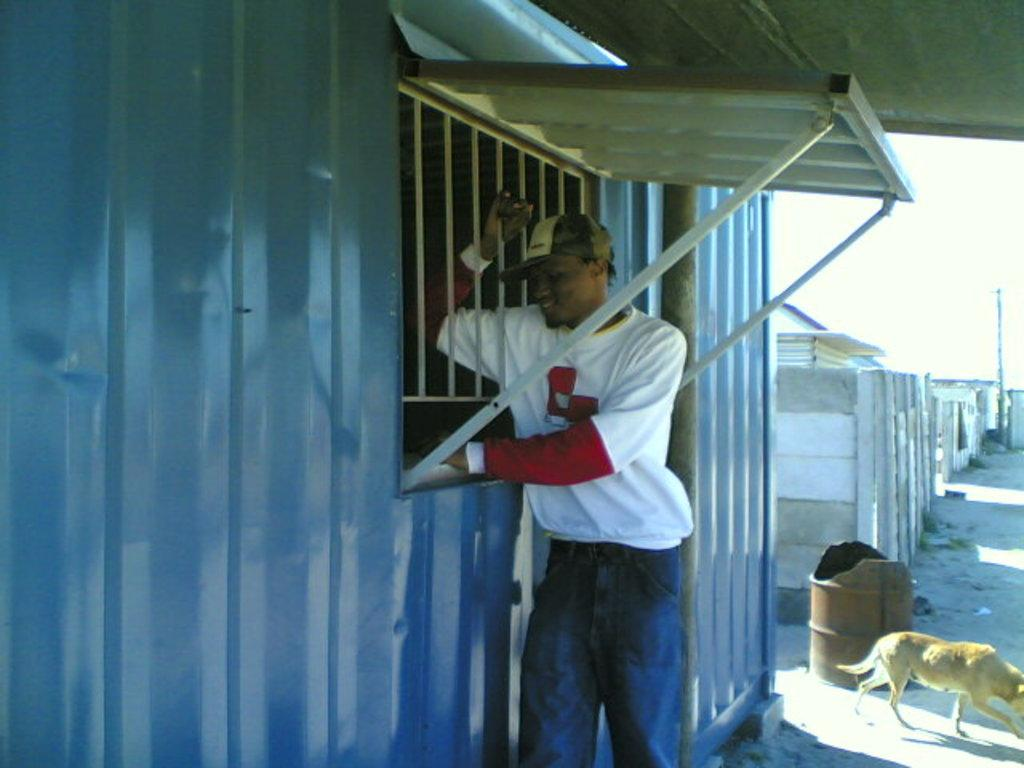What is the main subject of the image? There is a man standing in the image. Can you describe the man's attire? The man is wearing a cap. What can be seen in the background of the image? There is a window, a dog, a wall, a pole, and the sky visible in the background of the image. What type of celery is being used as a skate by the man in the image? There is no celery or skate present in the image; the man is simply standing. 